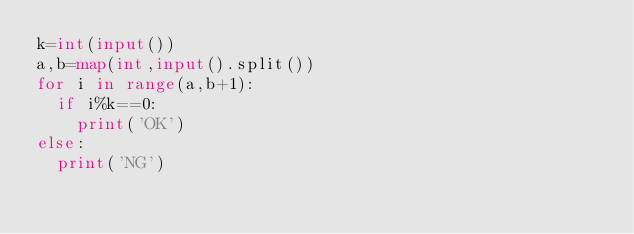<code> <loc_0><loc_0><loc_500><loc_500><_Python_>k=int(input())
a,b=map(int,input().split())
for i in range(a,b+1):
  if i%k==0:
    print('OK')
else:
  print('NG')
</code> 